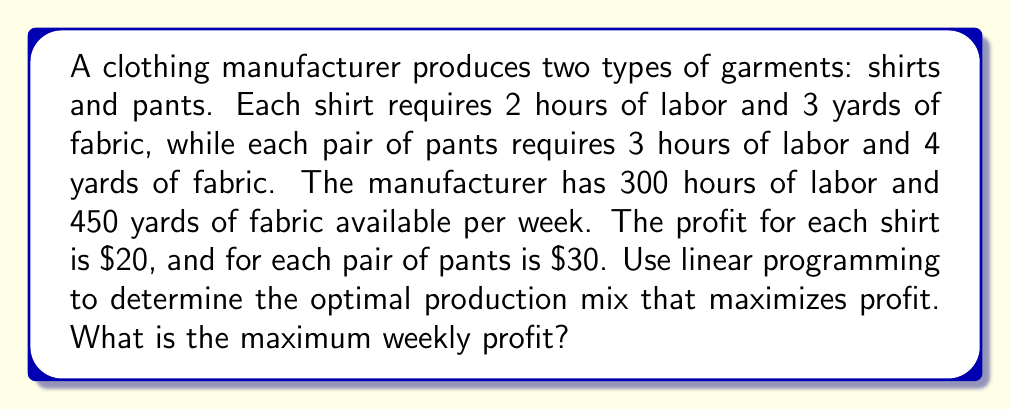Could you help me with this problem? Let's solve this problem using linear programming:

1. Define variables:
   Let $x$ = number of shirts produced
   Let $y$ = number of pants produced

2. Objective function (maximize profit):
   $P = 20x + 30y$

3. Constraints:
   Labor constraint: $2x + 3y \leq 300$
   Fabric constraint: $3x + 4y \leq 450$
   Non-negativity: $x \geq 0, y \geq 0$

4. Set up the linear programming problem:
   Maximize $P = 20x + 30y$
   Subject to:
   $2x + 3y \leq 300$
   $3x + 4y \leq 450$
   $x \geq 0, y \geq 0$

5. Solve using the graphical method:
   a) Plot the constraints:
      For $2x + 3y = 300$: When $x = 0, y = 100$; when $y = 0, x = 150$
      For $3x + 4y = 450$: When $x = 0, y = 112.5$; when $y = 0, x = 150$

   b) Identify the feasible region (area bounded by constraints and axes)

   c) Find corner points of the feasible region:
      $(0, 0)$, $(0, 100)$, $(90, 60)$, $(150, 0)$

   d) Evaluate the objective function at each corner point:
      $P(0, 0) = 0$
      $P(0, 100) = 3000$
      $P(90, 60) = 3600$
      $P(150, 0) = 3000$

6. The maximum profit occurs at the point $(90, 60)$, which means producing 90 shirts and 60 pants.

7. Calculate the maximum profit:
   $P_{max} = 20(90) + 30(60) = 1800 + 1800 = 3600$
Answer: The maximum weekly profit is $3600, achieved by producing 90 shirts and 60 pants. 